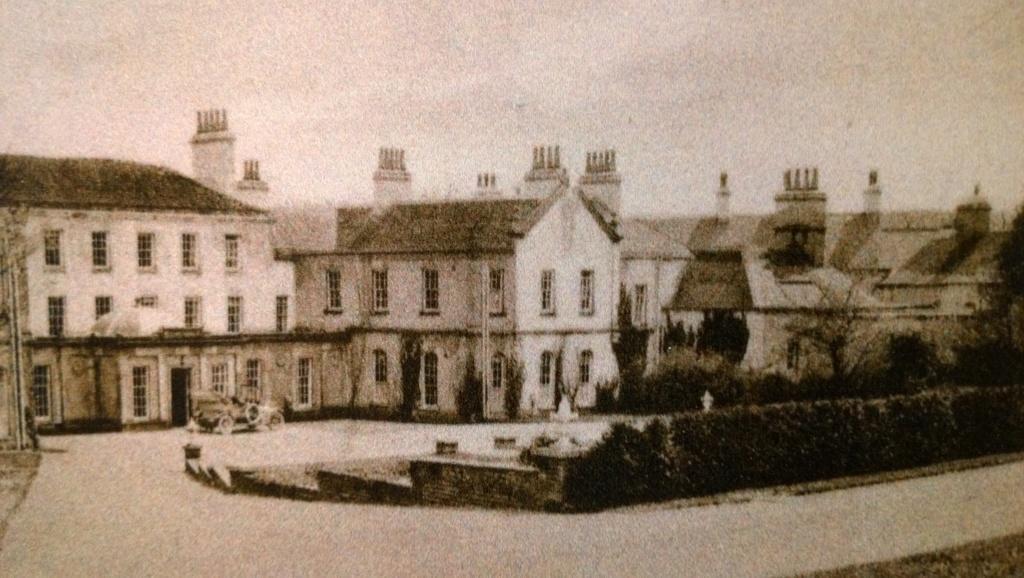Can you describe this image briefly? In this image we can see a black and white photography. In the photograph there are motor vehicle on the ground, buildings, sky, bushes and trees. 